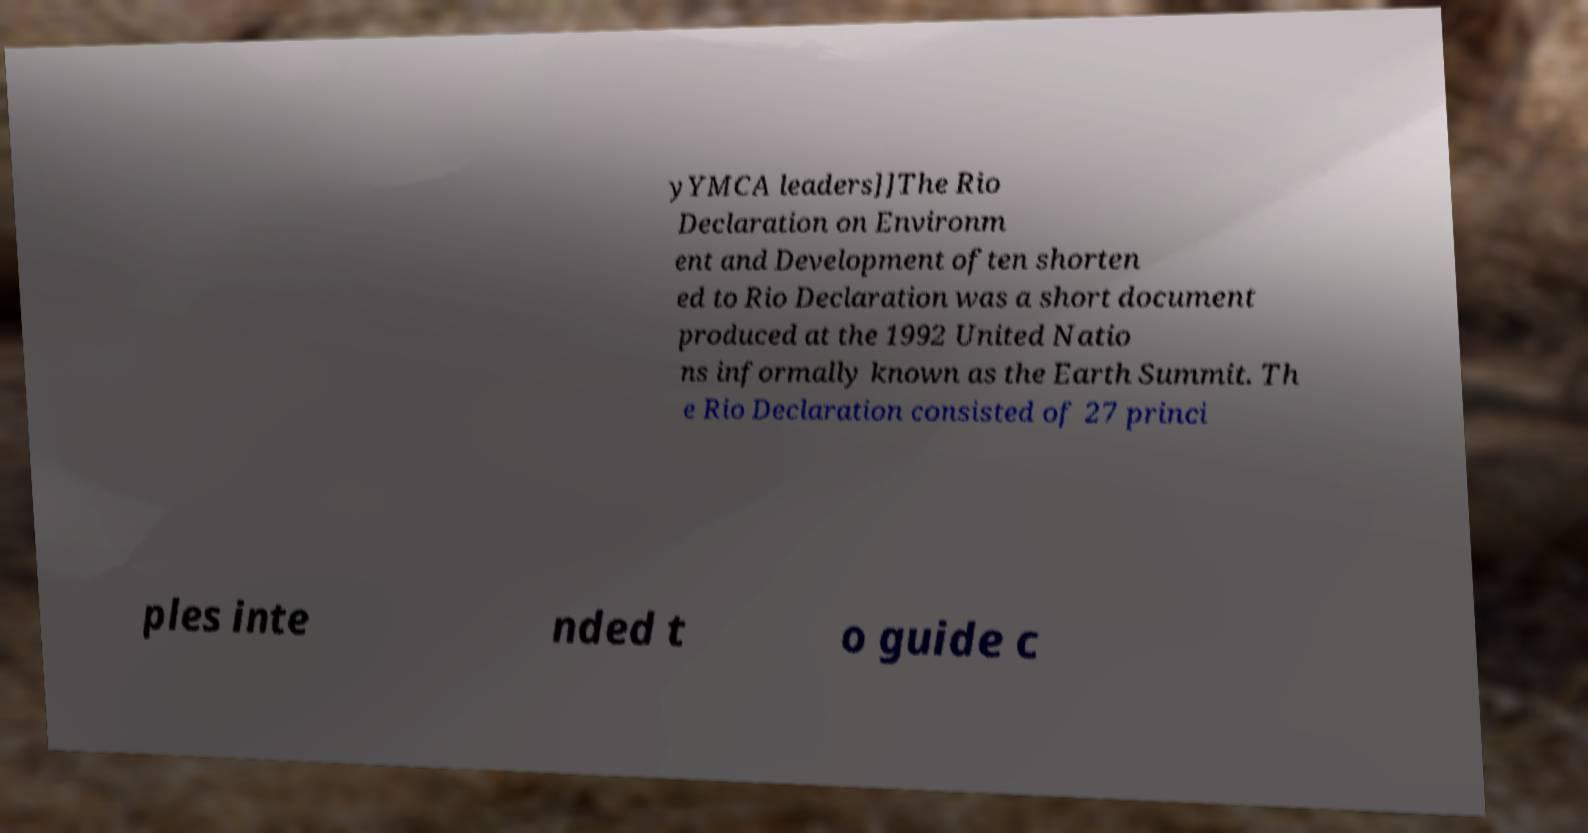I need the written content from this picture converted into text. Can you do that? yYMCA leaders]]The Rio Declaration on Environm ent and Development often shorten ed to Rio Declaration was a short document produced at the 1992 United Natio ns informally known as the Earth Summit. Th e Rio Declaration consisted of 27 princi ples inte nded t o guide c 